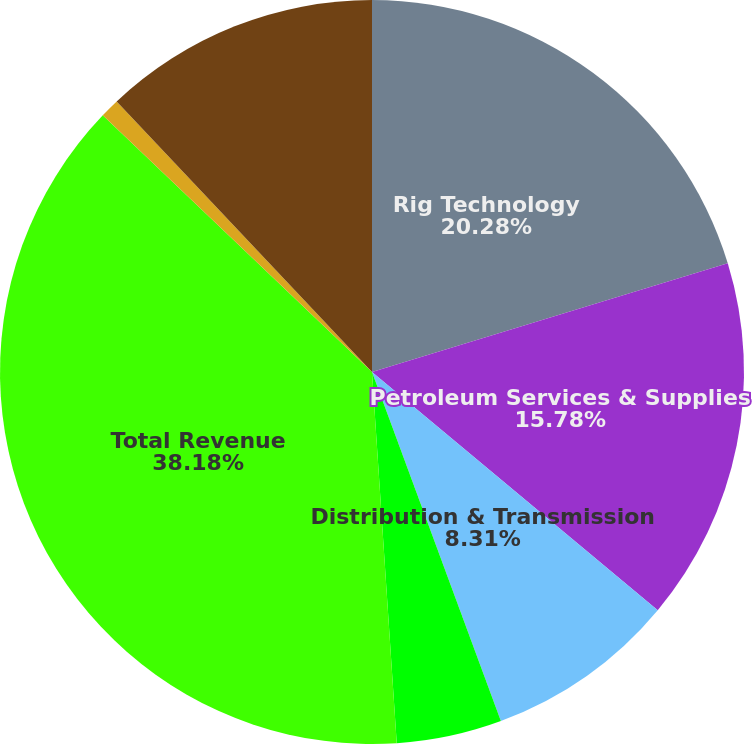Convert chart to OTSL. <chart><loc_0><loc_0><loc_500><loc_500><pie_chart><fcel>Rig Technology<fcel>Petroleum Services & Supplies<fcel>Distribution & Transmission<fcel>Eliminations<fcel>Total Revenue<fcel>Unallocated expenses and<fcel>Total Operating Profit<nl><fcel>20.28%<fcel>15.78%<fcel>8.31%<fcel>4.57%<fcel>38.18%<fcel>0.84%<fcel>12.04%<nl></chart> 